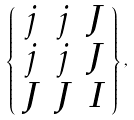Convert formula to latex. <formula><loc_0><loc_0><loc_500><loc_500>\left \{ \begin{array} { c c c } j & j & J \\ j & j & J \\ J & J & I \end{array} \right \} ,</formula> 